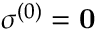<formula> <loc_0><loc_0><loc_500><loc_500>\sigma ^ { ( 0 ) } = 0</formula> 